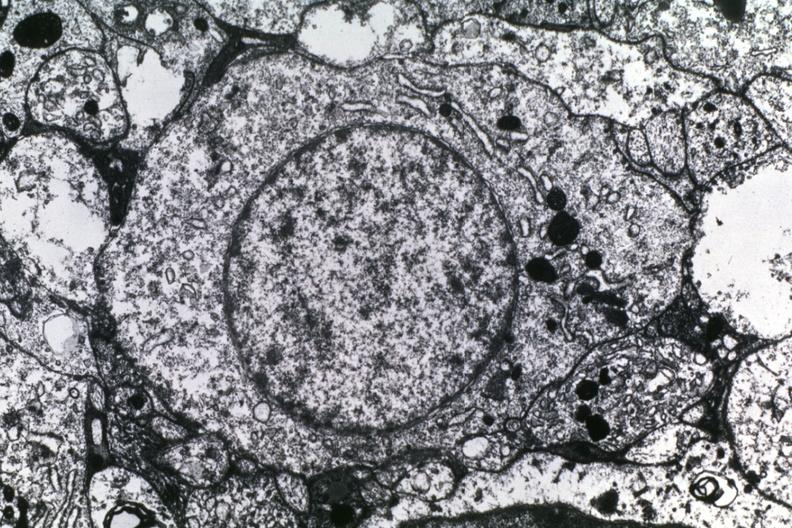does lower chest and abdomen anterior show dr garcia tumors 56?
Answer the question using a single word or phrase. No 